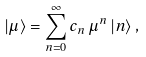Convert formula to latex. <formula><loc_0><loc_0><loc_500><loc_500>| \mu \rangle = \sum ^ { \infty } _ { n = 0 } c _ { n } \, \mu ^ { n } \, | n \rangle \, ,</formula> 